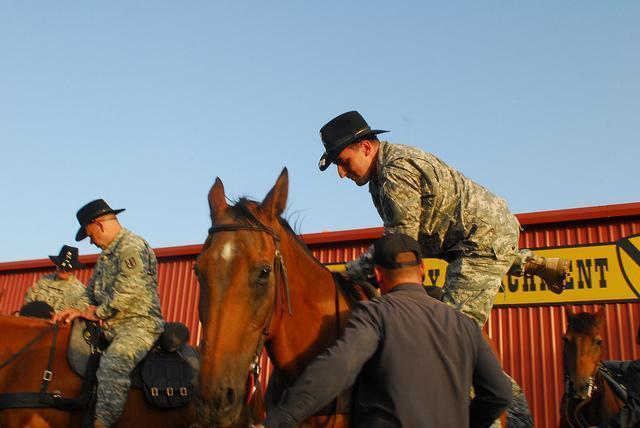How many people are in the picture?
Give a very brief answer. 4. How many horses can be seen?
Give a very brief answer. 3. How many blue buses are there?
Give a very brief answer. 0. 